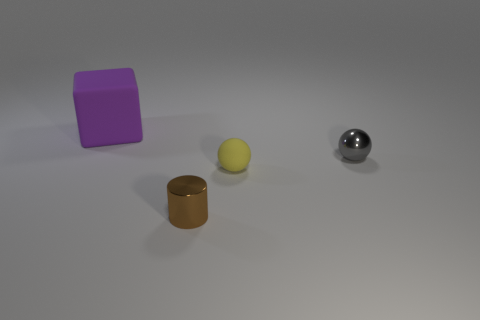Does the gray metallic thing have the same shape as the large matte object?
Make the answer very short. No. How many yellow rubber balls have the same size as the brown thing?
Offer a terse response. 1. What number of big things are either cylinders or gray blocks?
Offer a very short reply. 0. Is there a small blue metal cylinder?
Your answer should be very brief. No. Is the number of metallic objects that are on the left side of the small gray object greater than the number of tiny brown cylinders that are in front of the small yellow matte ball?
Keep it short and to the point. No. The shiny thing that is in front of the small shiny thing that is on the right side of the small brown thing is what color?
Give a very brief answer. Brown. Are there any tiny shiny things of the same color as the small rubber ball?
Keep it short and to the point. No. What size is the shiny object that is in front of the metallic object that is behind the rubber object that is right of the matte block?
Your answer should be very brief. Small. What shape is the brown shiny thing?
Your response must be concise. Cylinder. How many small gray objects are to the left of the shiny thing behind the brown object?
Your response must be concise. 0. 